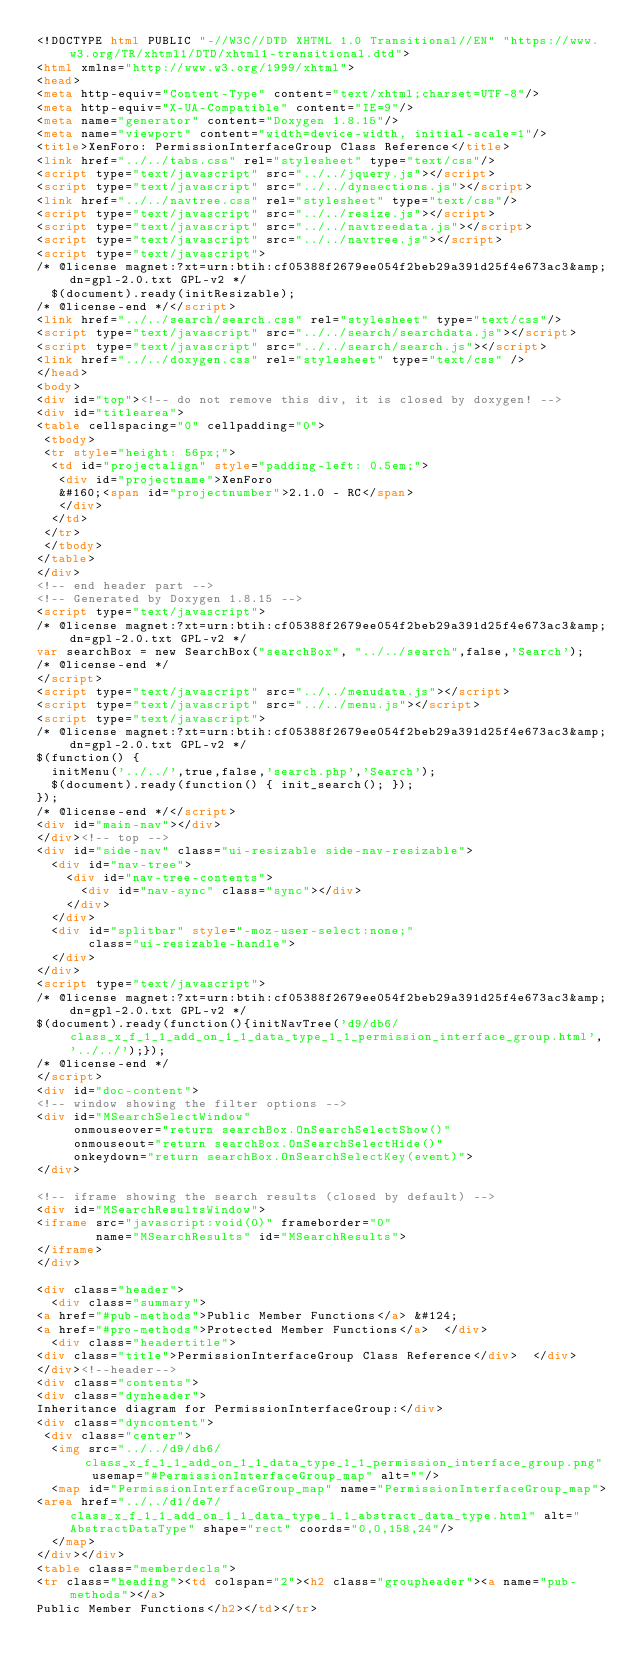Convert code to text. <code><loc_0><loc_0><loc_500><loc_500><_HTML_><!DOCTYPE html PUBLIC "-//W3C//DTD XHTML 1.0 Transitional//EN" "https://www.w3.org/TR/xhtml1/DTD/xhtml1-transitional.dtd">
<html xmlns="http://www.w3.org/1999/xhtml">
<head>
<meta http-equiv="Content-Type" content="text/xhtml;charset=UTF-8"/>
<meta http-equiv="X-UA-Compatible" content="IE=9"/>
<meta name="generator" content="Doxygen 1.8.15"/>
<meta name="viewport" content="width=device-width, initial-scale=1"/>
<title>XenForo: PermissionInterfaceGroup Class Reference</title>
<link href="../../tabs.css" rel="stylesheet" type="text/css"/>
<script type="text/javascript" src="../../jquery.js"></script>
<script type="text/javascript" src="../../dynsections.js"></script>
<link href="../../navtree.css" rel="stylesheet" type="text/css"/>
<script type="text/javascript" src="../../resize.js"></script>
<script type="text/javascript" src="../../navtreedata.js"></script>
<script type="text/javascript" src="../../navtree.js"></script>
<script type="text/javascript">
/* @license magnet:?xt=urn:btih:cf05388f2679ee054f2beb29a391d25f4e673ac3&amp;dn=gpl-2.0.txt GPL-v2 */
  $(document).ready(initResizable);
/* @license-end */</script>
<link href="../../search/search.css" rel="stylesheet" type="text/css"/>
<script type="text/javascript" src="../../search/searchdata.js"></script>
<script type="text/javascript" src="../../search/search.js"></script>
<link href="../../doxygen.css" rel="stylesheet" type="text/css" />
</head>
<body>
<div id="top"><!-- do not remove this div, it is closed by doxygen! -->
<div id="titlearea">
<table cellspacing="0" cellpadding="0">
 <tbody>
 <tr style="height: 56px;">
  <td id="projectalign" style="padding-left: 0.5em;">
   <div id="projectname">XenForo
   &#160;<span id="projectnumber">2.1.0 - RC</span>
   </div>
  </td>
 </tr>
 </tbody>
</table>
</div>
<!-- end header part -->
<!-- Generated by Doxygen 1.8.15 -->
<script type="text/javascript">
/* @license magnet:?xt=urn:btih:cf05388f2679ee054f2beb29a391d25f4e673ac3&amp;dn=gpl-2.0.txt GPL-v2 */
var searchBox = new SearchBox("searchBox", "../../search",false,'Search');
/* @license-end */
</script>
<script type="text/javascript" src="../../menudata.js"></script>
<script type="text/javascript" src="../../menu.js"></script>
<script type="text/javascript">
/* @license magnet:?xt=urn:btih:cf05388f2679ee054f2beb29a391d25f4e673ac3&amp;dn=gpl-2.0.txt GPL-v2 */
$(function() {
  initMenu('../../',true,false,'search.php','Search');
  $(document).ready(function() { init_search(); });
});
/* @license-end */</script>
<div id="main-nav"></div>
</div><!-- top -->
<div id="side-nav" class="ui-resizable side-nav-resizable">
  <div id="nav-tree">
    <div id="nav-tree-contents">
      <div id="nav-sync" class="sync"></div>
    </div>
  </div>
  <div id="splitbar" style="-moz-user-select:none;" 
       class="ui-resizable-handle">
  </div>
</div>
<script type="text/javascript">
/* @license magnet:?xt=urn:btih:cf05388f2679ee054f2beb29a391d25f4e673ac3&amp;dn=gpl-2.0.txt GPL-v2 */
$(document).ready(function(){initNavTree('d9/db6/class_x_f_1_1_add_on_1_1_data_type_1_1_permission_interface_group.html','../../');});
/* @license-end */
</script>
<div id="doc-content">
<!-- window showing the filter options -->
<div id="MSearchSelectWindow"
     onmouseover="return searchBox.OnSearchSelectShow()"
     onmouseout="return searchBox.OnSearchSelectHide()"
     onkeydown="return searchBox.OnSearchSelectKey(event)">
</div>

<!-- iframe showing the search results (closed by default) -->
<div id="MSearchResultsWindow">
<iframe src="javascript:void(0)" frameborder="0" 
        name="MSearchResults" id="MSearchResults">
</iframe>
</div>

<div class="header">
  <div class="summary">
<a href="#pub-methods">Public Member Functions</a> &#124;
<a href="#pro-methods">Protected Member Functions</a>  </div>
  <div class="headertitle">
<div class="title">PermissionInterfaceGroup Class Reference</div>  </div>
</div><!--header-->
<div class="contents">
<div class="dynheader">
Inheritance diagram for PermissionInterfaceGroup:</div>
<div class="dyncontent">
 <div class="center">
  <img src="../../d9/db6/class_x_f_1_1_add_on_1_1_data_type_1_1_permission_interface_group.png" usemap="#PermissionInterfaceGroup_map" alt=""/>
  <map id="PermissionInterfaceGroup_map" name="PermissionInterfaceGroup_map">
<area href="../../d1/de7/class_x_f_1_1_add_on_1_1_data_type_1_1_abstract_data_type.html" alt="AbstractDataType" shape="rect" coords="0,0,158,24"/>
  </map>
</div></div>
<table class="memberdecls">
<tr class="heading"><td colspan="2"><h2 class="groupheader"><a name="pub-methods"></a>
Public Member Functions</h2></td></tr></code> 